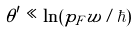<formula> <loc_0><loc_0><loc_500><loc_500>\theta ^ { \prime } \ll \ln ( p _ { F } w / \hbar { ) }</formula> 